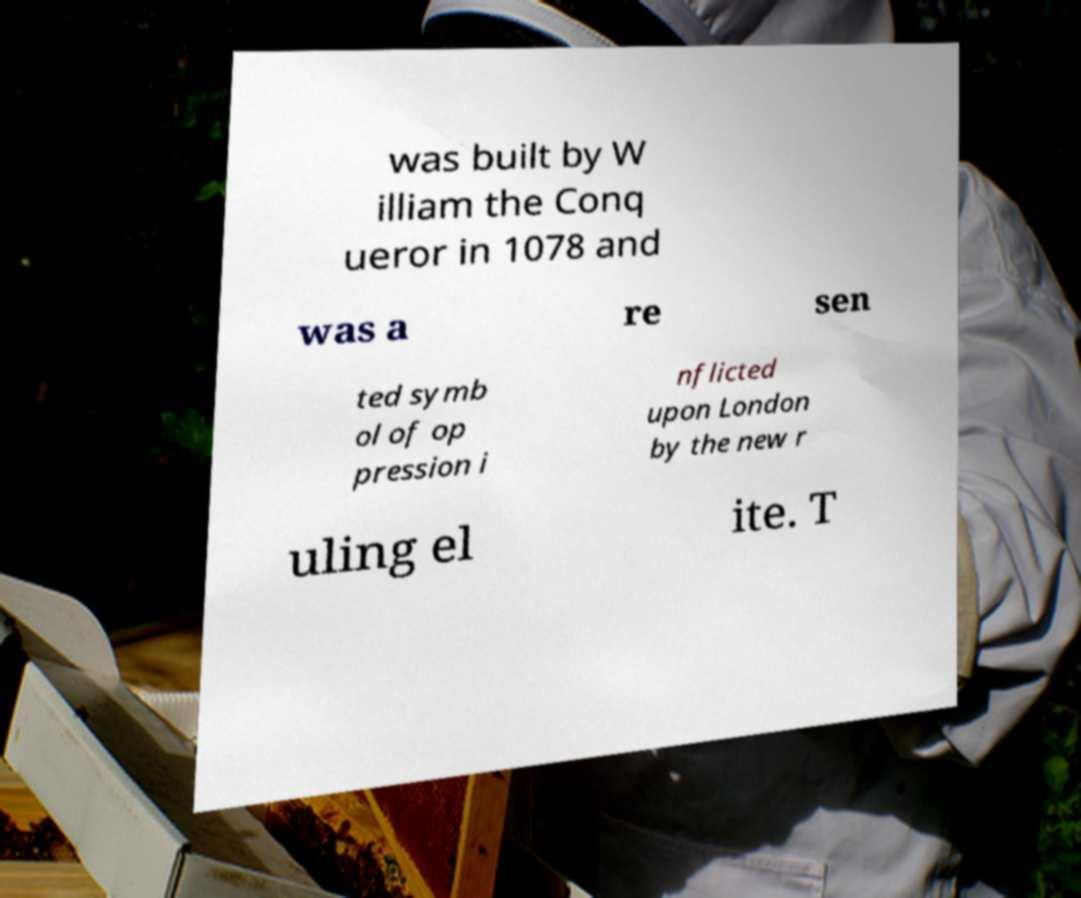There's text embedded in this image that I need extracted. Can you transcribe it verbatim? was built by W illiam the Conq ueror in 1078 and was a re sen ted symb ol of op pression i nflicted upon London by the new r uling el ite. T 